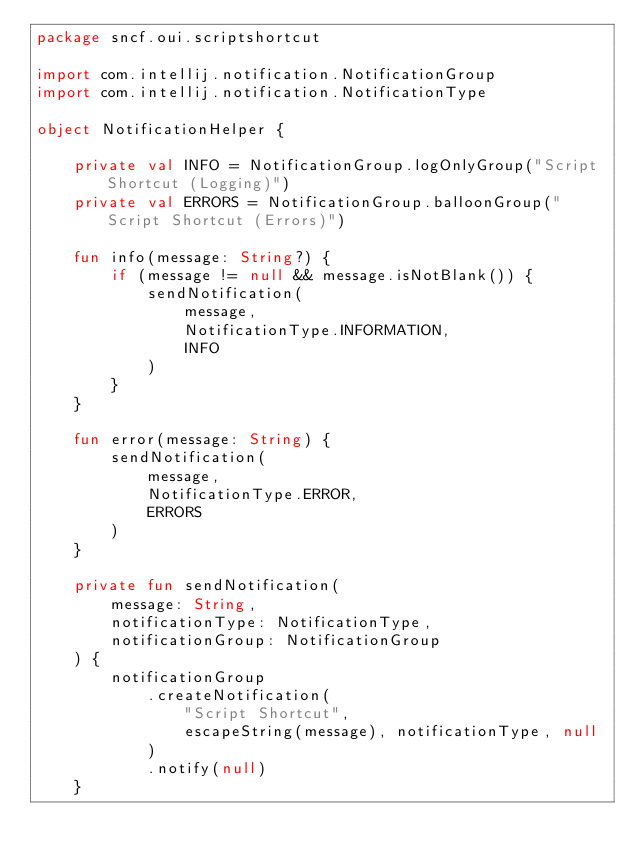<code> <loc_0><loc_0><loc_500><loc_500><_Kotlin_>package sncf.oui.scriptshortcut

import com.intellij.notification.NotificationGroup
import com.intellij.notification.NotificationType

object NotificationHelper {

    private val INFO = NotificationGroup.logOnlyGroup("Script Shortcut (Logging)")
    private val ERRORS = NotificationGroup.balloonGroup("Script Shortcut (Errors)")

    fun info(message: String?) {
        if (message != null && message.isNotBlank()) {
            sendNotification(
                message,
                NotificationType.INFORMATION,
                INFO
            )
        }
    }

    fun error(message: String) {
        sendNotification(
            message,
            NotificationType.ERROR,
            ERRORS
        )
    }

    private fun sendNotification(
        message: String,
        notificationType: NotificationType,
        notificationGroup: NotificationGroup
    ) {
        notificationGroup
            .createNotification(
                "Script Shortcut",
                escapeString(message), notificationType, null
            )
            .notify(null)
    }
</code> 